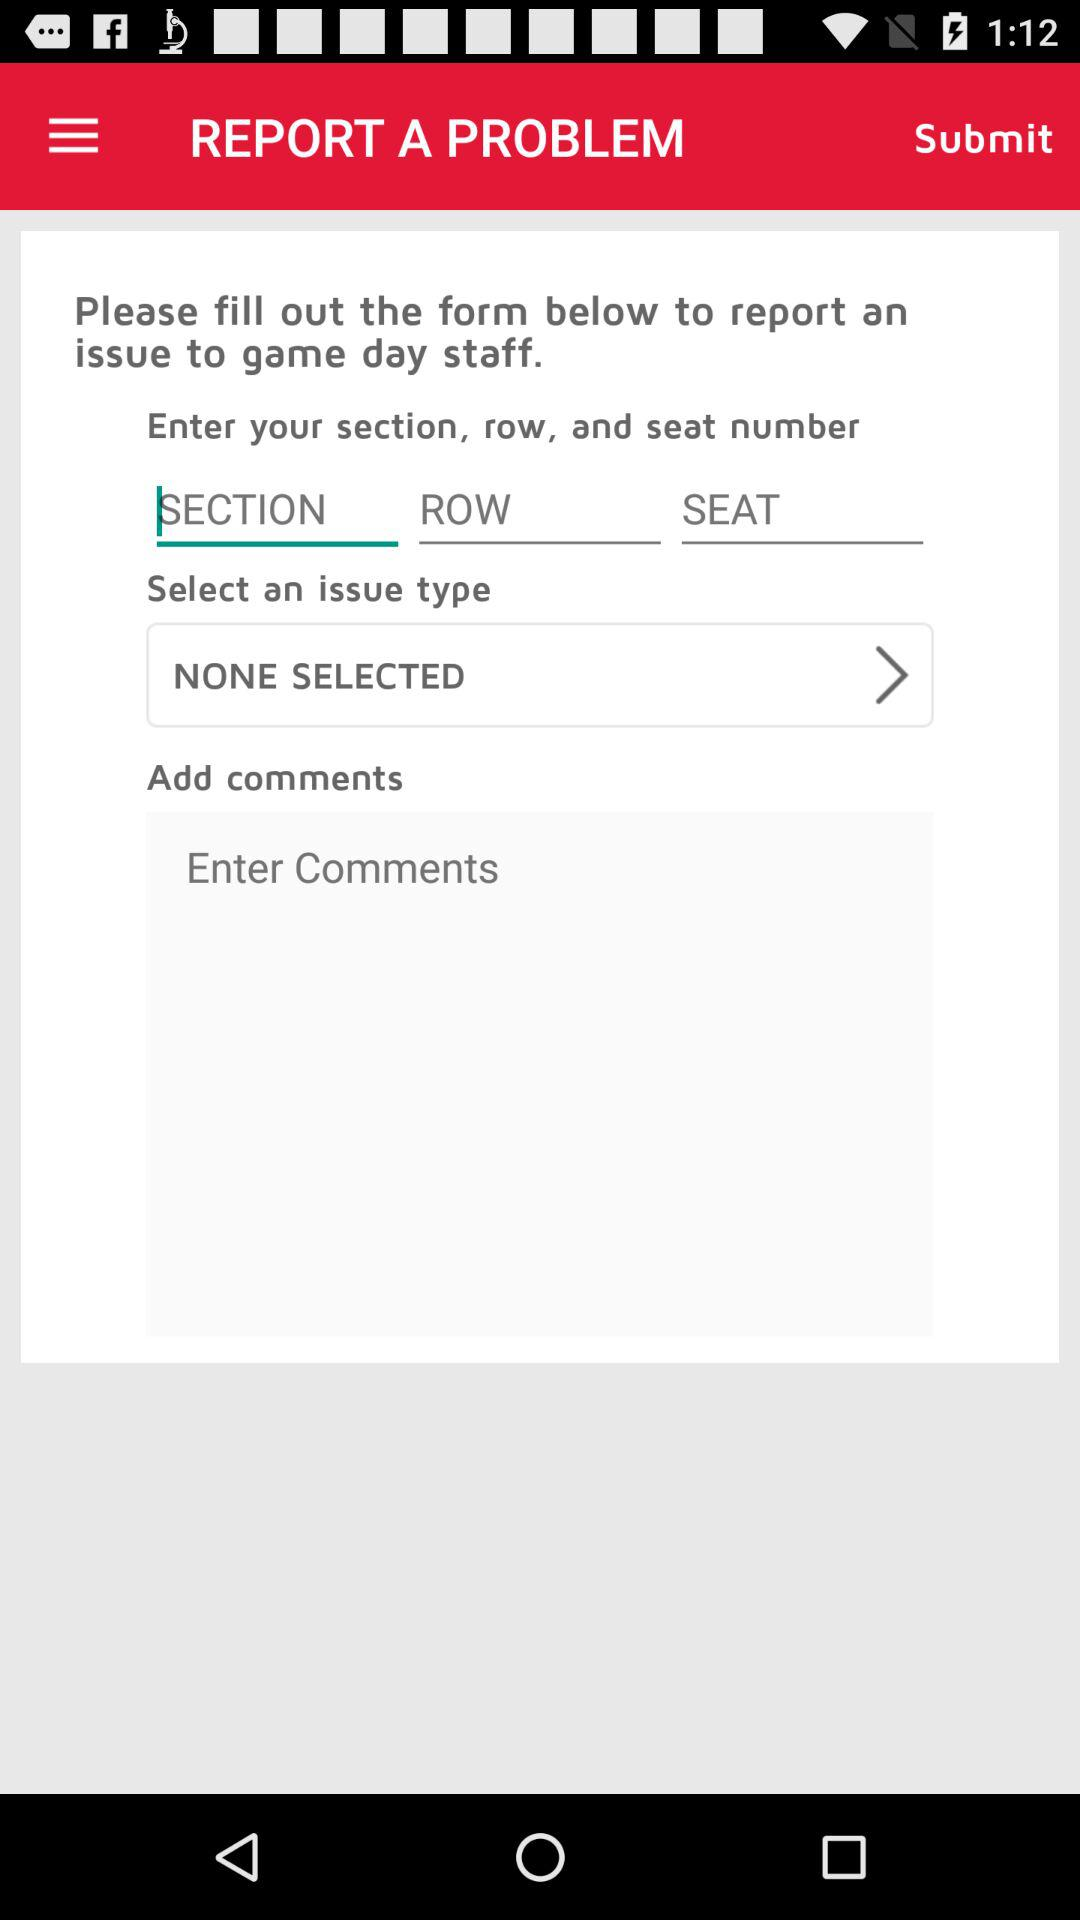Which issue type is selected? The selected issue type is "NONE SELECTED". 